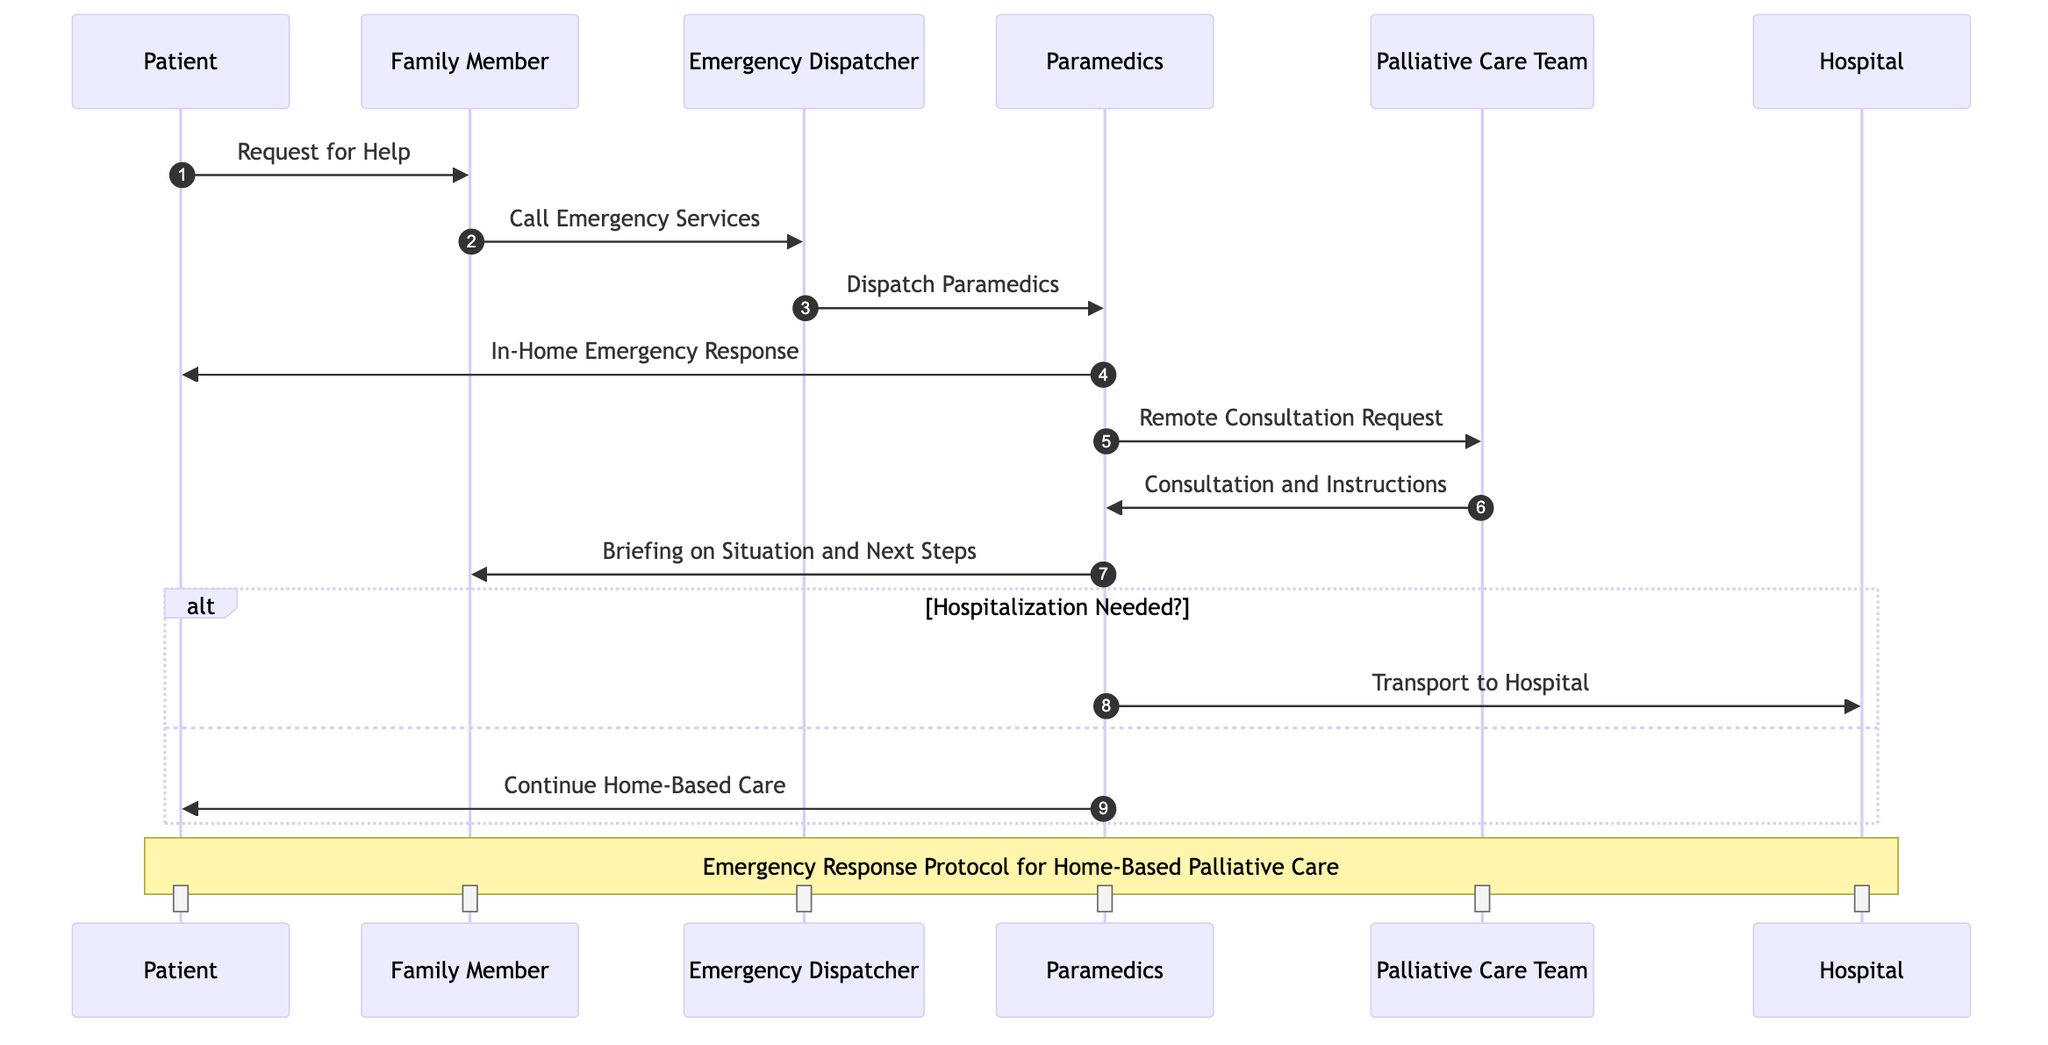What is the first action taken in this emergency response process? The first action is the Patient requesting help from the Family Member. This is indicated by the arrow from Patient to Family Member labeled "Request for Help."
Answer: Request for Help How many participants are involved in the diagram? The diagram features six distinct participants, which are the Patient, Family Member, Emergency Dispatcher, Paramedics, Palliative Care Team, and Hospital. This count includes all the unique role representations.
Answer: Six What message do Paramedics send to the Family Member? Paramedics send a message to the Family Member providing a briefing on the situation and next steps. This message is explicitly shown in the diagram following the remote consultation actions.
Answer: Briefing on Situation and Next Steps What decision does the diagram include regarding the patient's care? The diagram includes a decision on whether hospitalization is needed or if home-based care should continue. This decision is presented as an alternative path after the consultation with the Palliative Care Team.
Answer: Hospitalization Needed? What happens if hospitalization is required? If hospitalization is required, the Paramedics will transport the patient to the Hospital, which is depicted in the true path of the decision-making process.
Answer: Transport to Hospital Which participant is contacted after the Emergency Dispatcher? After the Emergency Dispatcher, the next participant contacted is the Paramedics, as depicted by the message flow from Emergency Dispatcher to Paramedics labeled "Dispatch Paramedics."
Answer: Paramedics How do Paramedics get consultation from the Palliative Care Team? Paramedics request a remote consultation from the Palliative Care Team, as indicated by the arrow leading from Paramedics to Palliative Care Team labeled "Remote Consultation Request."
Answer: Remote Consultation Request What information do the Paramedics provide to the Patient if they decide to continue home-based care? If they decide to continue home-based care, the Paramedics inform the Patient about continuing to provide care, as shown in the false path of the decision node.
Answer: Continue Home-Based Care 